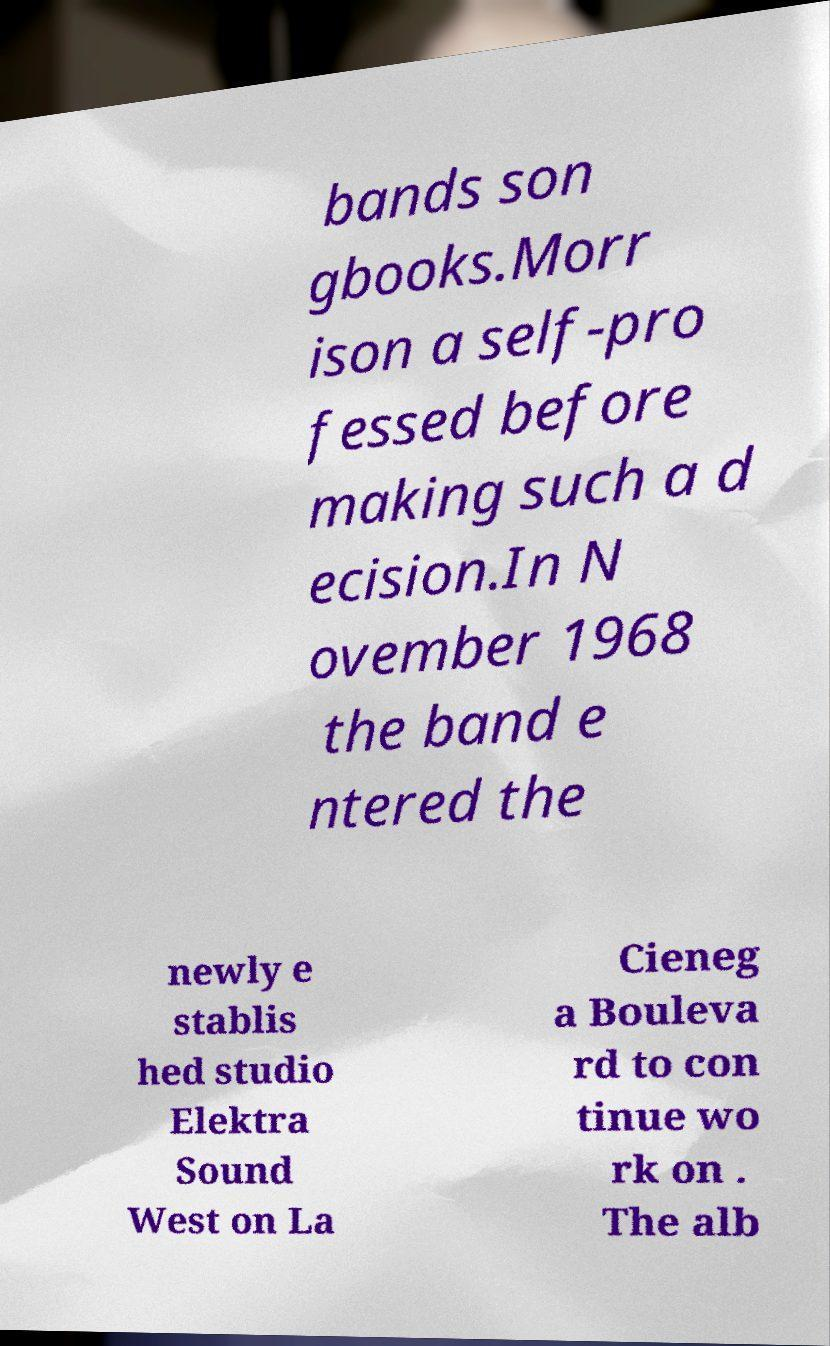Could you assist in decoding the text presented in this image and type it out clearly? bands son gbooks.Morr ison a self-pro fessed before making such a d ecision.In N ovember 1968 the band e ntered the newly e stablis hed studio Elektra Sound West on La Cieneg a Bouleva rd to con tinue wo rk on . The alb 